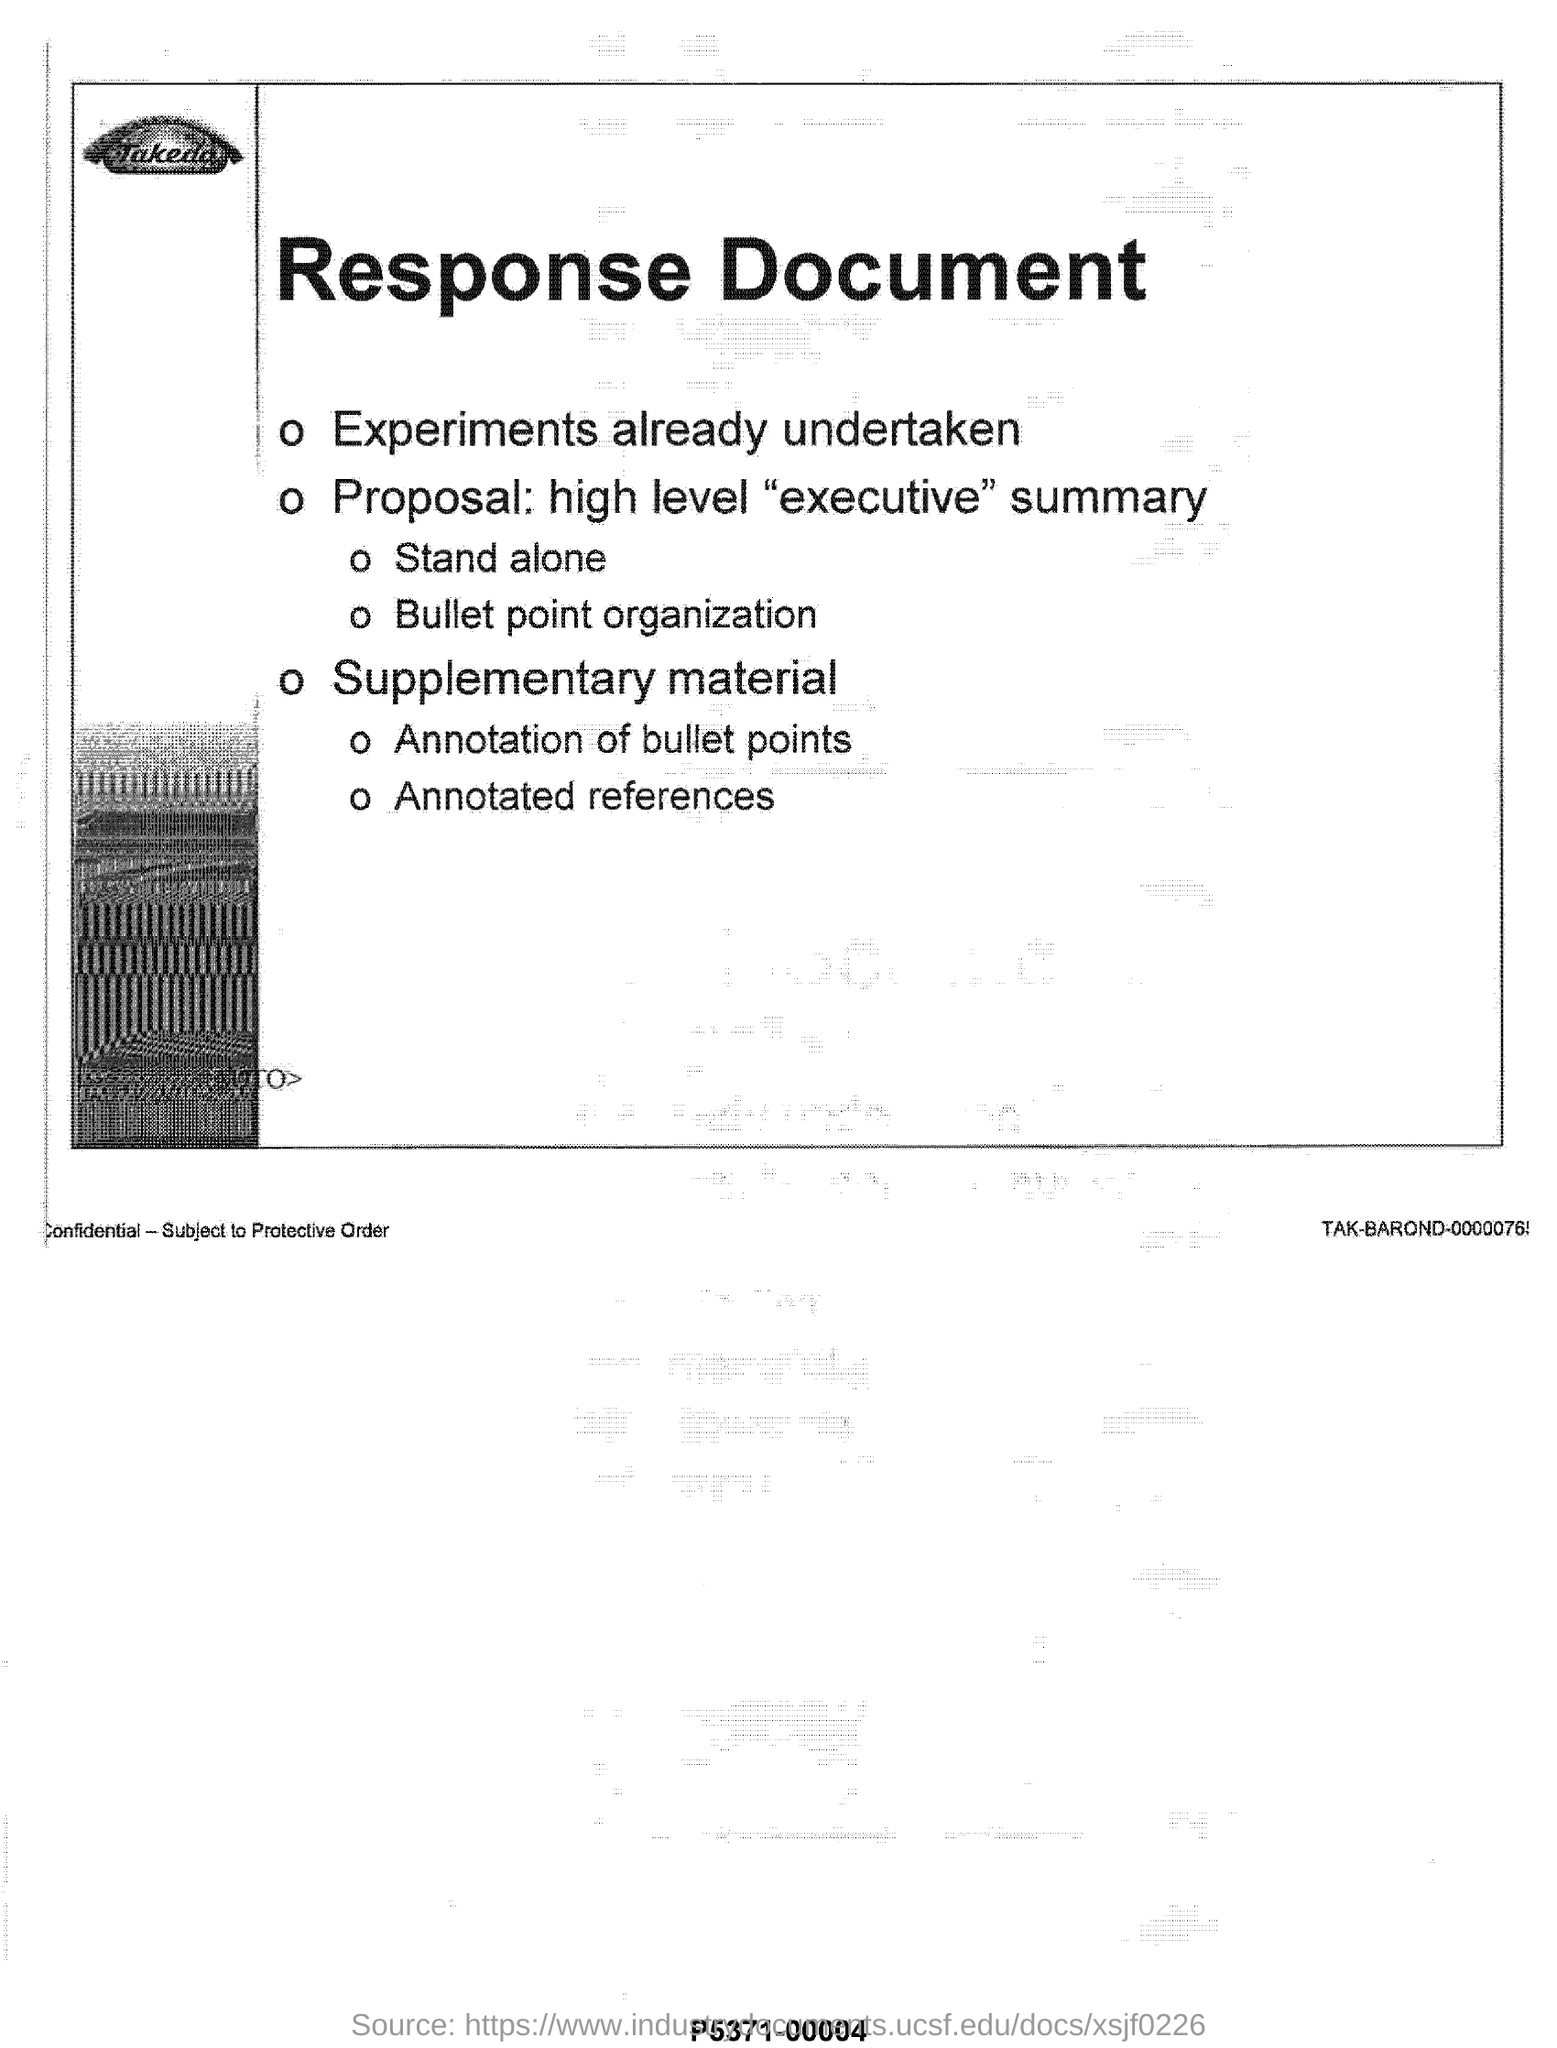List a handful of essential elements in this visual. The heading of the document is the response document. 